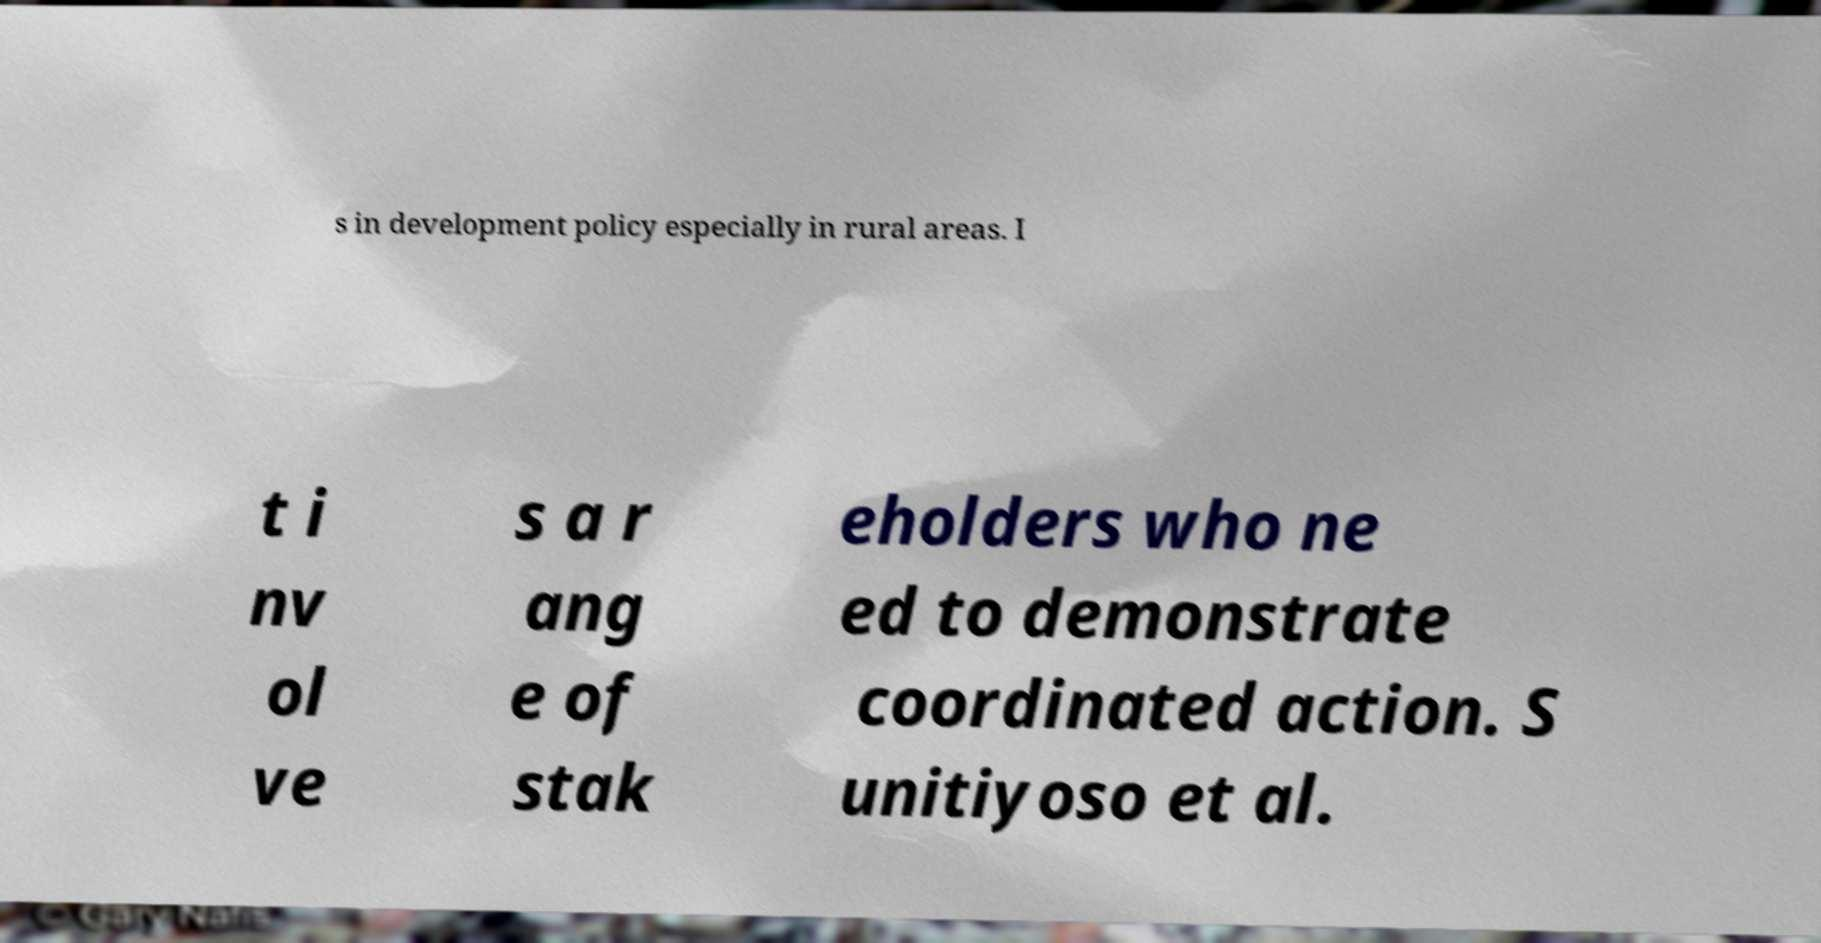Could you extract and type out the text from this image? s in development policy especially in rural areas. I t i nv ol ve s a r ang e of stak eholders who ne ed to demonstrate coordinated action. S unitiyoso et al. 